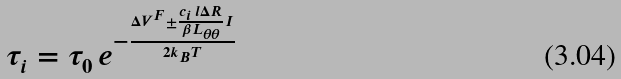<formula> <loc_0><loc_0><loc_500><loc_500>\tau _ { i } = \tau _ { 0 } \, e ^ { - \frac { \Delta V ^ { F } \pm \frac { c _ { i } \, l \Delta R } { \beta L _ { \theta \theta } } I } { 2 k _ { B } T } }</formula> 